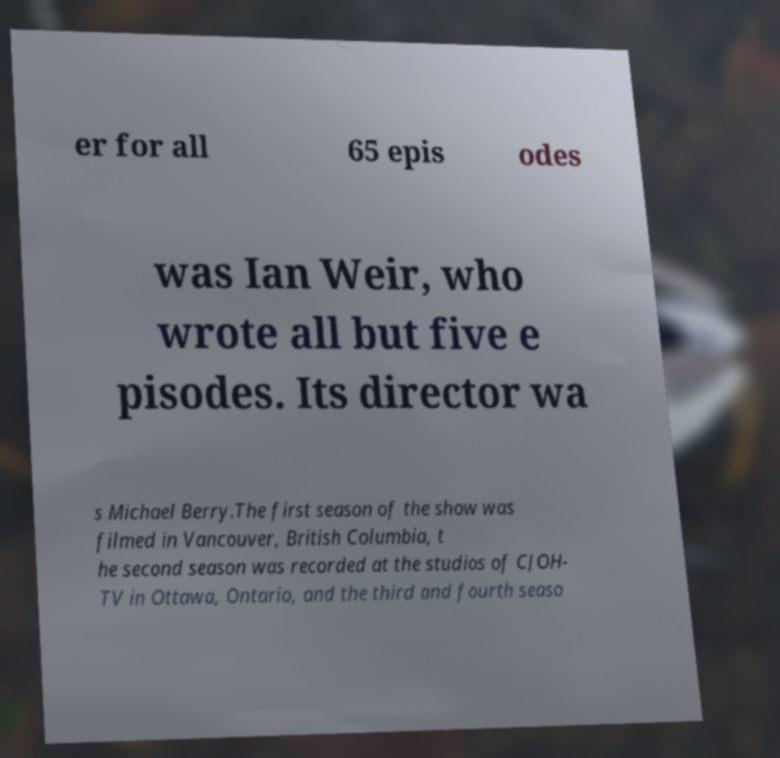Could you assist in decoding the text presented in this image and type it out clearly? er for all 65 epis odes was Ian Weir, who wrote all but five e pisodes. Its director wa s Michael Berry.The first season of the show was filmed in Vancouver, British Columbia, t he second season was recorded at the studios of CJOH- TV in Ottawa, Ontario, and the third and fourth seaso 